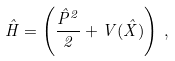Convert formula to latex. <formula><loc_0><loc_0><loc_500><loc_500>\hat { H } = \left ( \frac { \hat { P } ^ { 2 } } { 2 } + V ( \hat { X } ) \right ) \, ,</formula> 